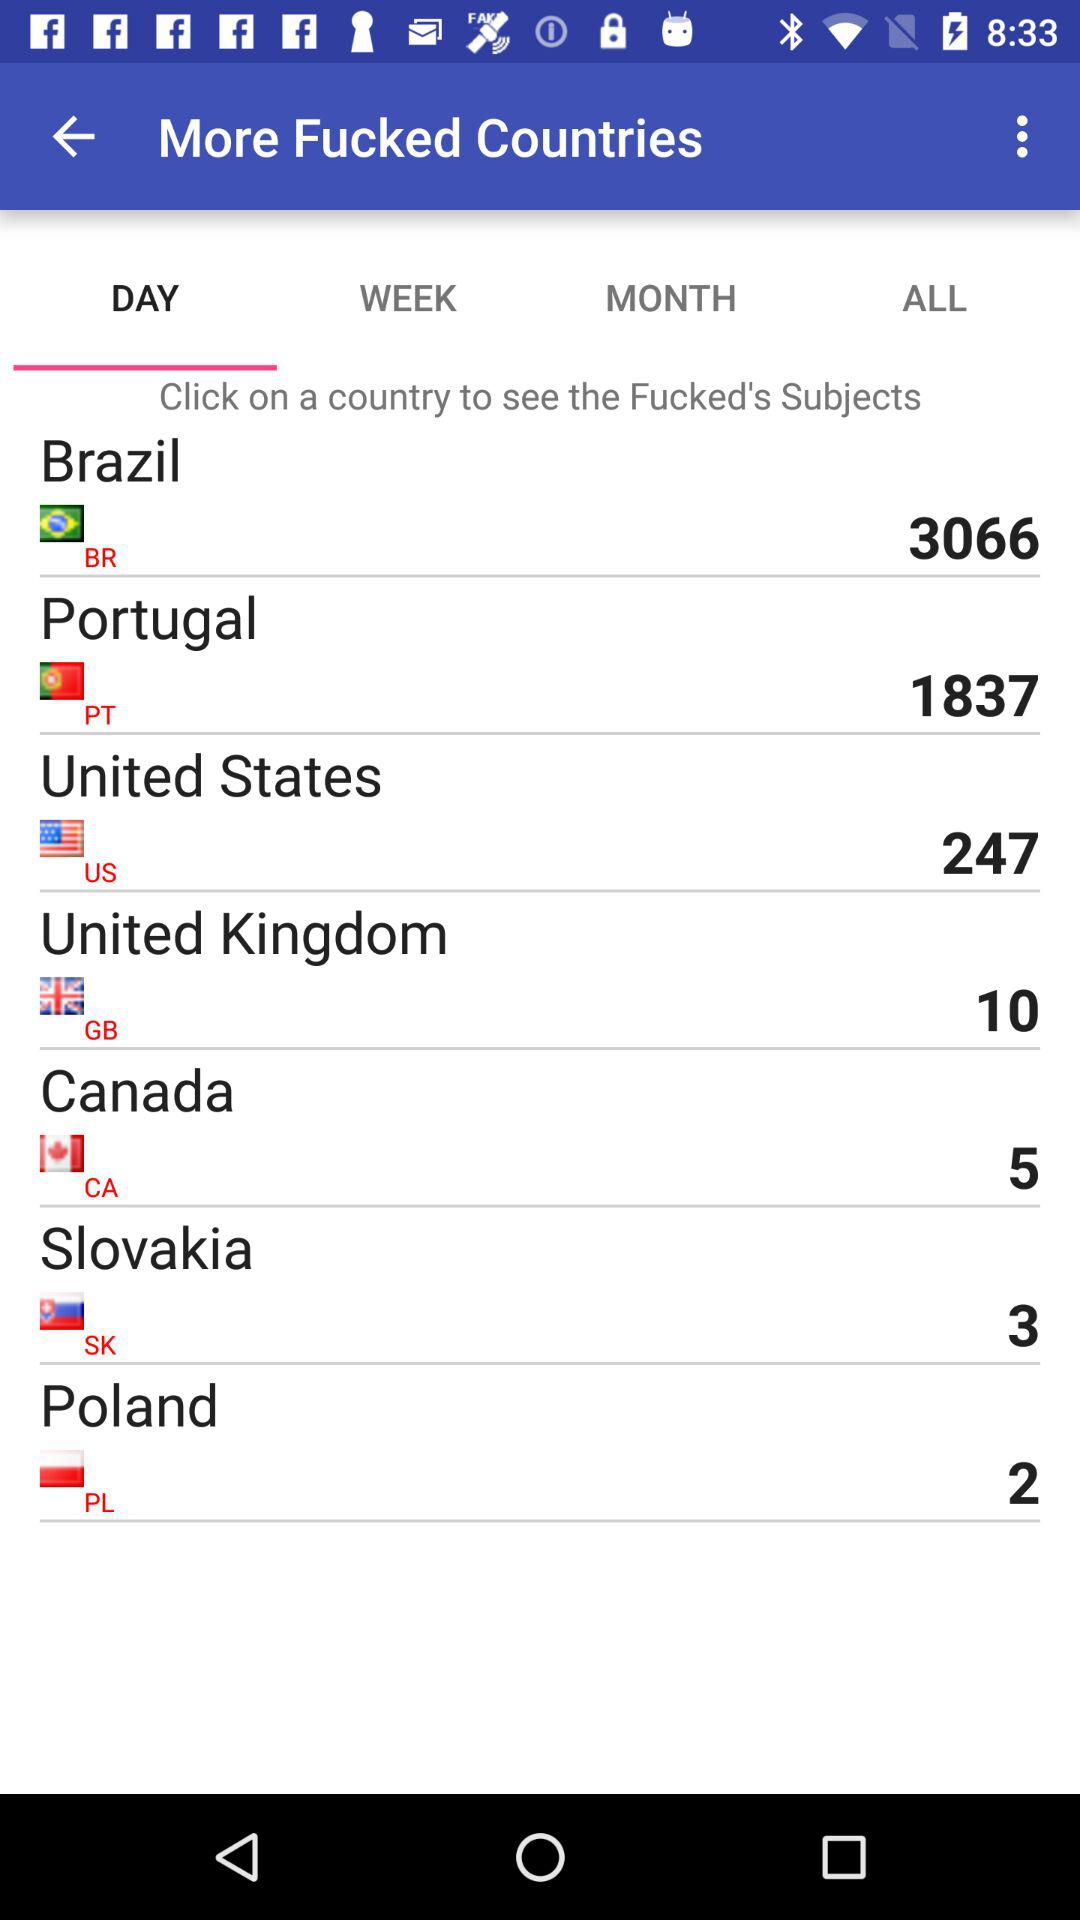What is the count mentioned for Poland? The count mentioned for Poland is 2. 